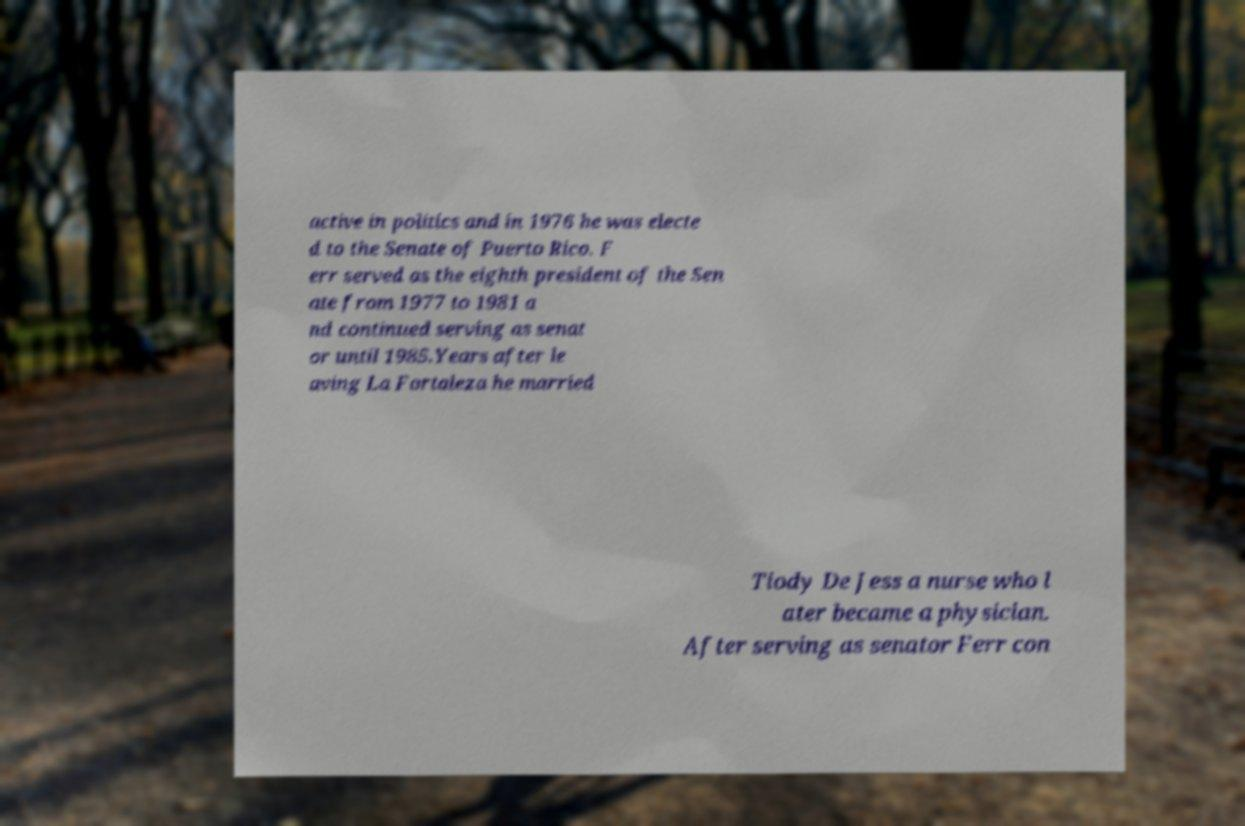Could you assist in decoding the text presented in this image and type it out clearly? active in politics and in 1976 he was electe d to the Senate of Puerto Rico. F err served as the eighth president of the Sen ate from 1977 to 1981 a nd continued serving as senat or until 1985.Years after le aving La Fortaleza he married Tiody De Jess a nurse who l ater became a physician. After serving as senator Ferr con 